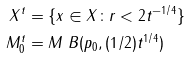<formula> <loc_0><loc_0><loc_500><loc_500>X ^ { t } & = \{ x \in X \colon r < 2 t ^ { - 1 / 4 } \} \\ M _ { 0 } ^ { t } & = M \ B ( p _ { 0 } , ( 1 / 2 ) t ^ { 1 / 4 } )</formula> 